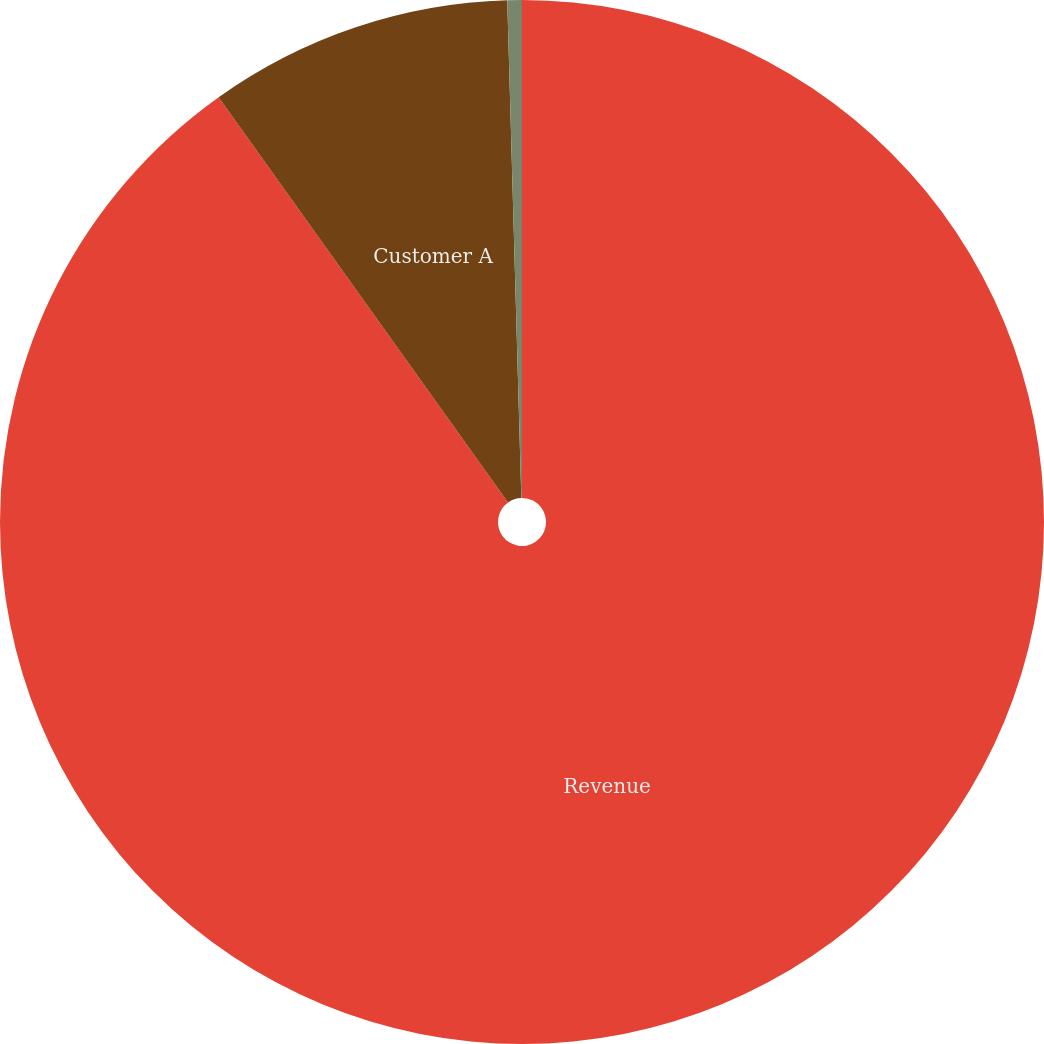<chart> <loc_0><loc_0><loc_500><loc_500><pie_chart><fcel>Revenue<fcel>Customer A<fcel>Customer B<nl><fcel>90.14%<fcel>9.42%<fcel>0.45%<nl></chart> 